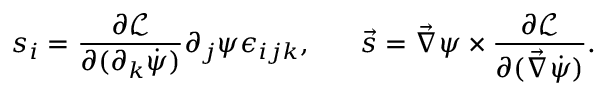Convert formula to latex. <formula><loc_0><loc_0><loc_500><loc_500>s _ { i } = \frac { \partial \mathcal { L } } { \partial ( \partial _ { k } \dot { \psi } ) } \partial _ { j } \psi \epsilon _ { i j k } , \, \vec { s } = \vec { \nabla } \psi \times \frac { \partial \mathcal { L } } { \partial ( \vec { \nabla } \dot { \psi } ) } .</formula> 